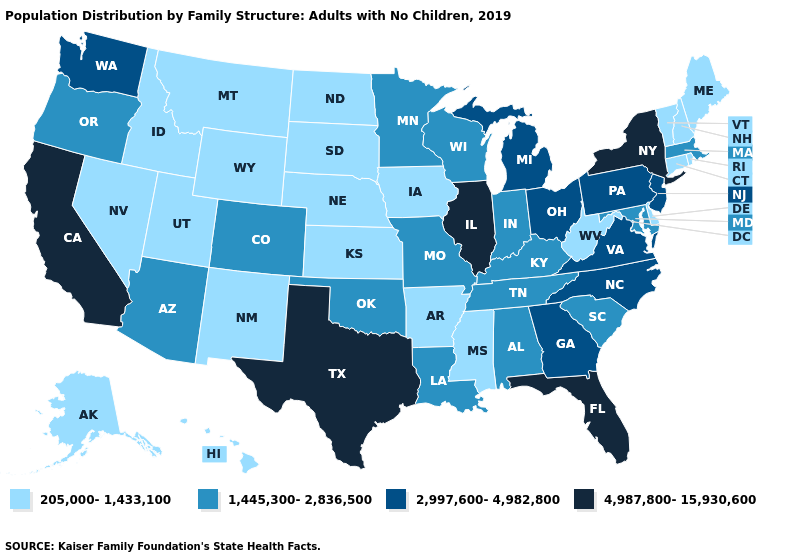Does Delaware have the same value as Florida?
Answer briefly. No. Among the states that border Connecticut , does Rhode Island have the lowest value?
Be succinct. Yes. What is the lowest value in the West?
Keep it brief. 205,000-1,433,100. Does California have a higher value than South Carolina?
Be succinct. Yes. What is the value of Arizona?
Quick response, please. 1,445,300-2,836,500. Name the states that have a value in the range 1,445,300-2,836,500?
Concise answer only. Alabama, Arizona, Colorado, Indiana, Kentucky, Louisiana, Maryland, Massachusetts, Minnesota, Missouri, Oklahoma, Oregon, South Carolina, Tennessee, Wisconsin. What is the highest value in the MidWest ?
Write a very short answer. 4,987,800-15,930,600. What is the value of New Hampshire?
Quick response, please. 205,000-1,433,100. Which states have the lowest value in the West?
Write a very short answer. Alaska, Hawaii, Idaho, Montana, Nevada, New Mexico, Utah, Wyoming. Name the states that have a value in the range 4,987,800-15,930,600?
Give a very brief answer. California, Florida, Illinois, New York, Texas. Does Nevada have the lowest value in the USA?
Keep it brief. Yes. Name the states that have a value in the range 1,445,300-2,836,500?
Be succinct. Alabama, Arizona, Colorado, Indiana, Kentucky, Louisiana, Maryland, Massachusetts, Minnesota, Missouri, Oklahoma, Oregon, South Carolina, Tennessee, Wisconsin. Name the states that have a value in the range 4,987,800-15,930,600?
Quick response, please. California, Florida, Illinois, New York, Texas. What is the highest value in the USA?
Write a very short answer. 4,987,800-15,930,600. Does the map have missing data?
Concise answer only. No. 